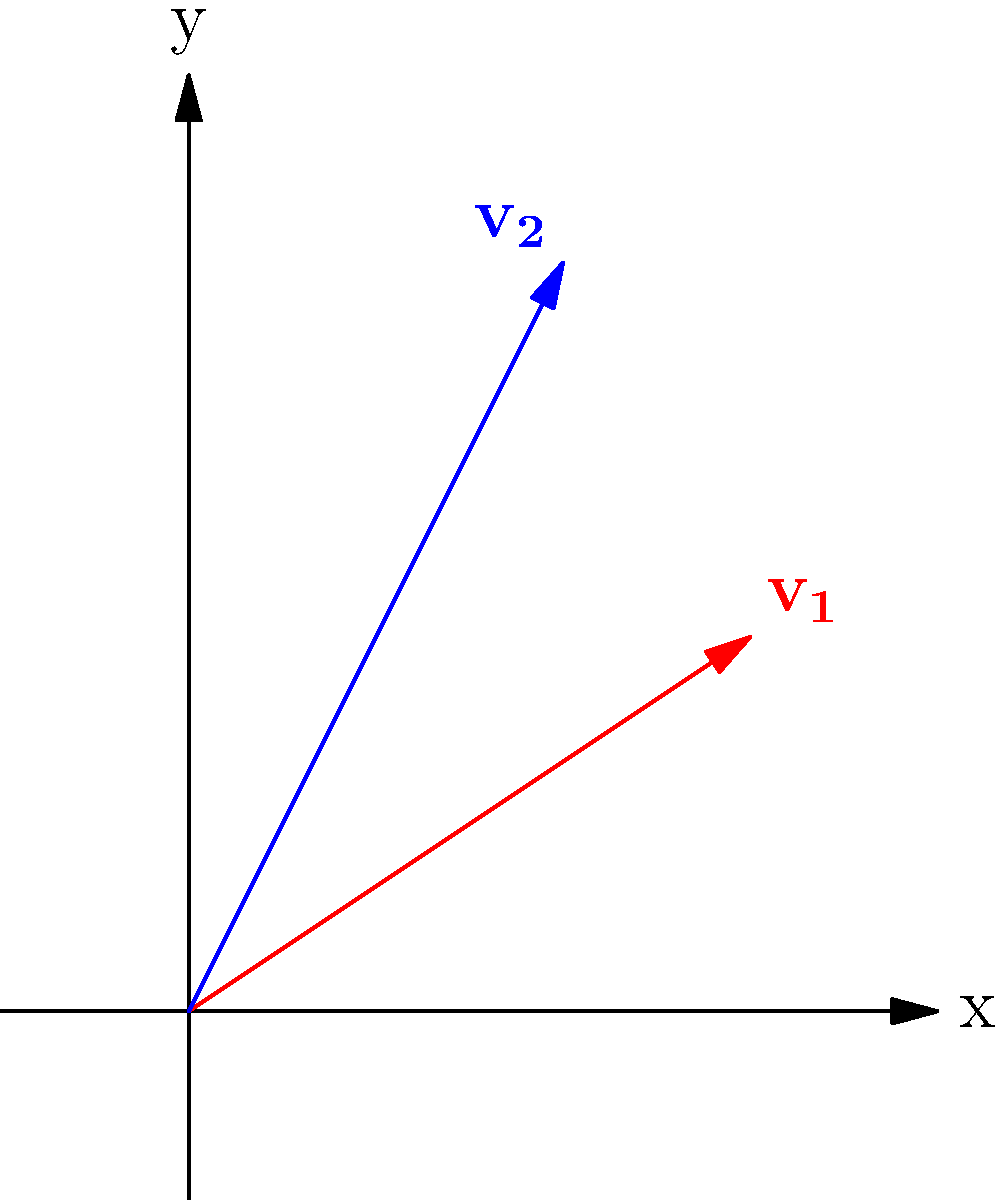As a stay-at-home dad, you want to optimize your daily chore efficiency. You have two tasks: cleaning the living room (represented by vector $\mathbf{v_1} = (3,2)$) and doing the laundry (represented by vector $\mathbf{v_2} = (2,4)$). The x-component represents the time taken (in hours), and the y-component represents the energy expended (on a scale of 1-5). Calculate the dot product of these two vectors to determine how well these tasks align in terms of time and energy expenditure. To solve this problem, we'll follow these steps:

1) Recall the formula for the dot product of two vectors:
   $\mathbf{v_1} \cdot \mathbf{v_2} = x_1x_2 + y_1y_2$

2) Identify the components of each vector:
   $\mathbf{v_1} = (3,2)$, so $x_1 = 3$ and $y_1 = 2$
   $\mathbf{v_2} = (2,4)$, so $x_2 = 2$ and $y_2 = 4$

3) Substitute these values into the dot product formula:
   $\mathbf{v_1} \cdot \mathbf{v_2} = (3)(2) + (2)(4)$

4) Perform the multiplication:
   $\mathbf{v_1} \cdot \mathbf{v_2} = 6 + 8$

5) Sum the results:
   $\mathbf{v_1} \cdot \mathbf{v_2} = 14$

The dot product of 14 indicates a moderate positive alignment between the two tasks in terms of time and energy expenditure. This suggests that these chores can be efficiently paired in your daily routine.
Answer: 14 